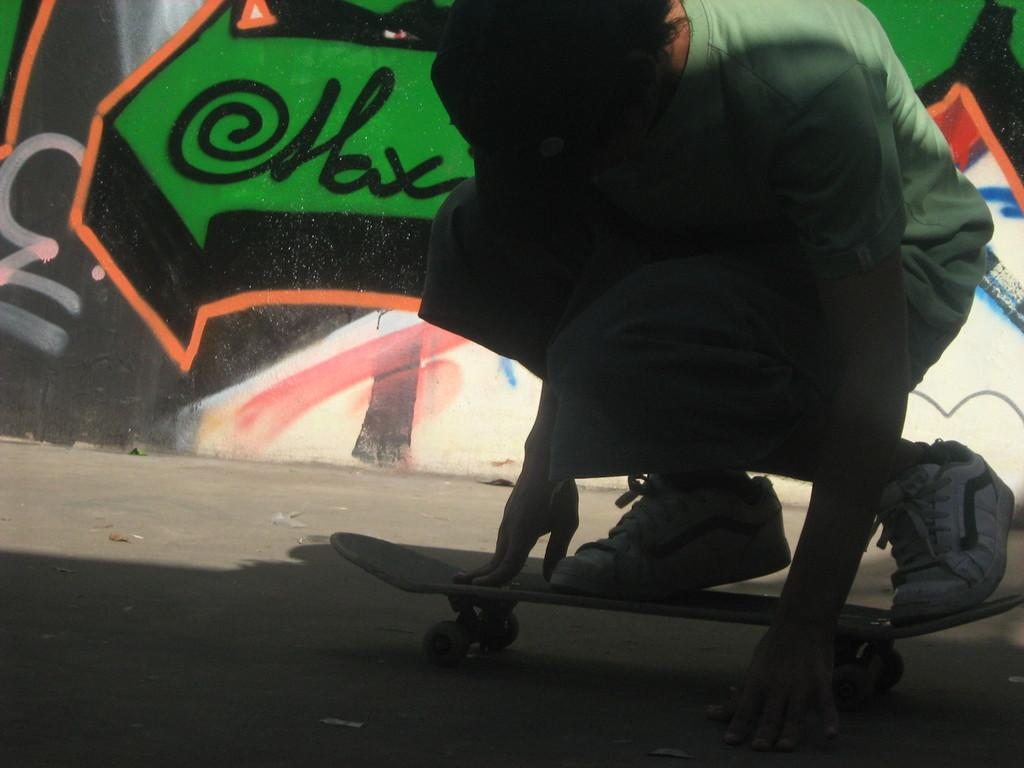What is the main subject of the image? The main subject of the image is a kid. What is the kid doing in the image? The kid is on a skateboard in the image. What type of surface is visible beneath the kid? There is a floor visible in the image. What can be seen on the wall in the background of the image? There is graffiti on the wall in the background of the image. What type of vacation is the kid planning based on the graffiti in the image? There is no indication in the image that the kid is planning a vacation or that the graffiti is related to any vacation plans. 